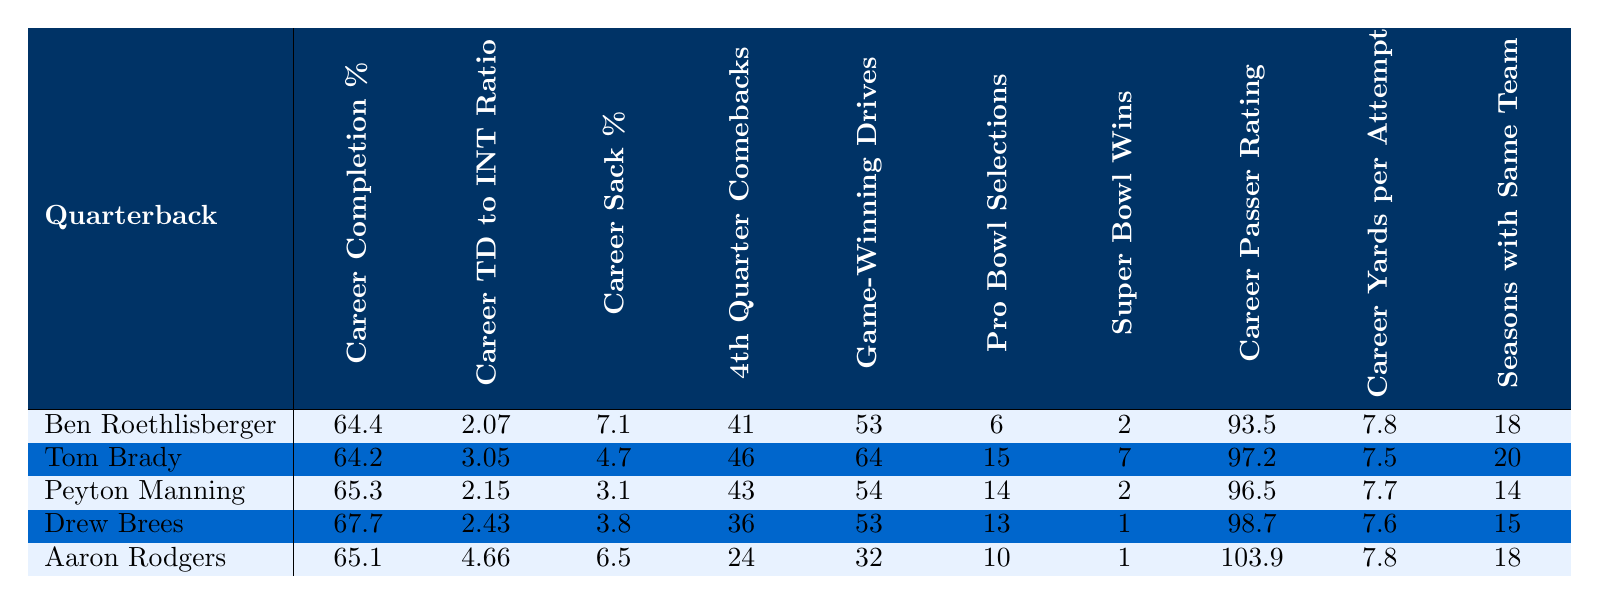What is Ben Roethlisberger's career completion percentage? According to the table, Ben Roethlisberger has a career completion percentage of 64.4%.
Answer: 64.4% Which quarterback has the highest career TD to INT ratio? By comparing the ratios in the table, Aaron Rodgers has the highest ratio of 4.66 compared to others.
Answer: Aaron Rodgers How many Pro Bowl selections does Drew Brees have? Looking at the table, Drew Brees has made 13 Pro Bowl selections.
Answer: 13 What is the difference in career fourth quarter comebacks between Tom Brady and Ben Roethlisberger? Tom Brady has 46 comebacks, while Ben Roethlisberger has 41. The difference is 46 - 41 = 5.
Answer: 5 Which quarterback has the most game-winning drives? Tom Brady has 64 game-winning drives, the highest of all the quarterbacks listed in the table.
Answer: Tom Brady Is it true that Roethlisberger and Manning both have the same number of Super Bowl wins? The table shows that both Roethlisberger and Manning have 2 Super Bowl wins, making the statement true.
Answer: Yes What is the average career passer rating of the quarterbacks listed? To find the average passer rating, add all ratings (93.5 + 97.2 + 96.5 + 98.7 + 103.9) = 489.8 and divide by 5. The average is 489.8 / 5 = 97.96.
Answer: 97.96 Which two quarterbacks have the same career yards per attempt? Upon inspecting the table, both Ben Roethlisberger and Aaron Rodgers have a career yards per attempt of 7.8.
Answer: Ben Roethlisberger and Aaron Rodgers How many seasons does Peyton Manning play with the same team? The table states that Peyton Manning played 14 seasons with the same team.
Answer: 14 If we consider the lowest sack percentage, which quarterback is it? The table indicates that Peyton Manning has the lowest sack percentage at 3.1%.
Answer: Peyton Manning 